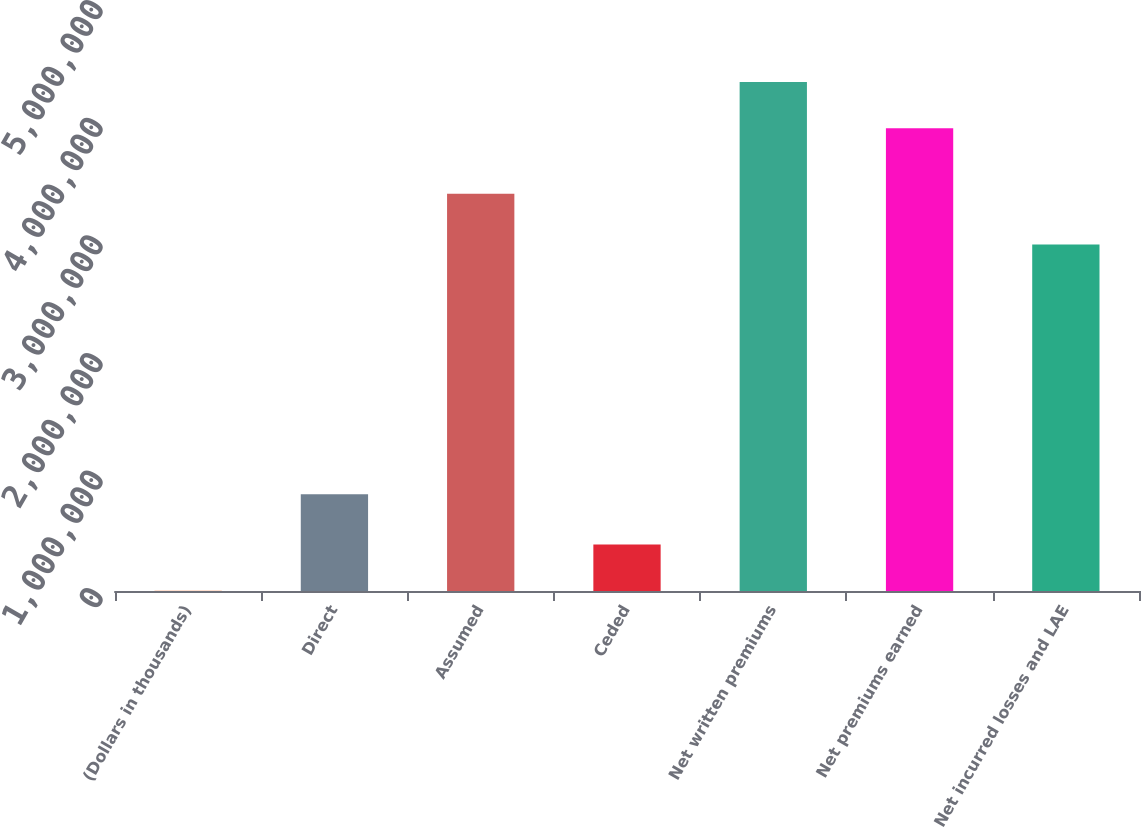<chart> <loc_0><loc_0><loc_500><loc_500><bar_chart><fcel>(Dollars in thousands)<fcel>Direct<fcel>Assumed<fcel>Ceded<fcel>Net written premiums<fcel>Net premiums earned<fcel>Net incurred losses and LAE<nl><fcel>2010<fcel>823378<fcel>3.37734e+06<fcel>396367<fcel>4.32898e+06<fcel>3.93462e+06<fcel>2.94571e+06<nl></chart> 